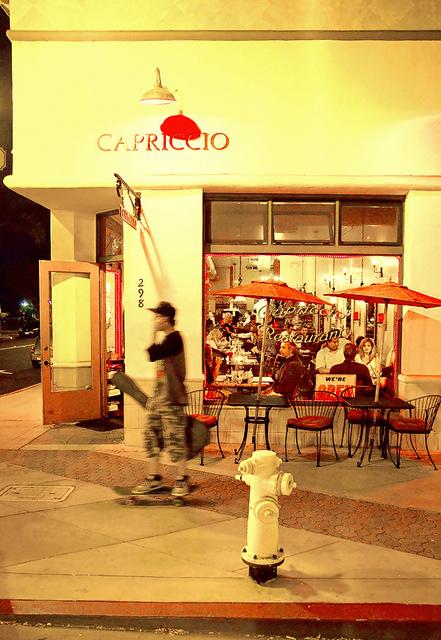Is he holding a guitar case?
Concise answer only. Yes. How many umbrellas are there?
Answer briefly. 2. Is the door to the restaurant open or closed?
Give a very brief answer. Open. 